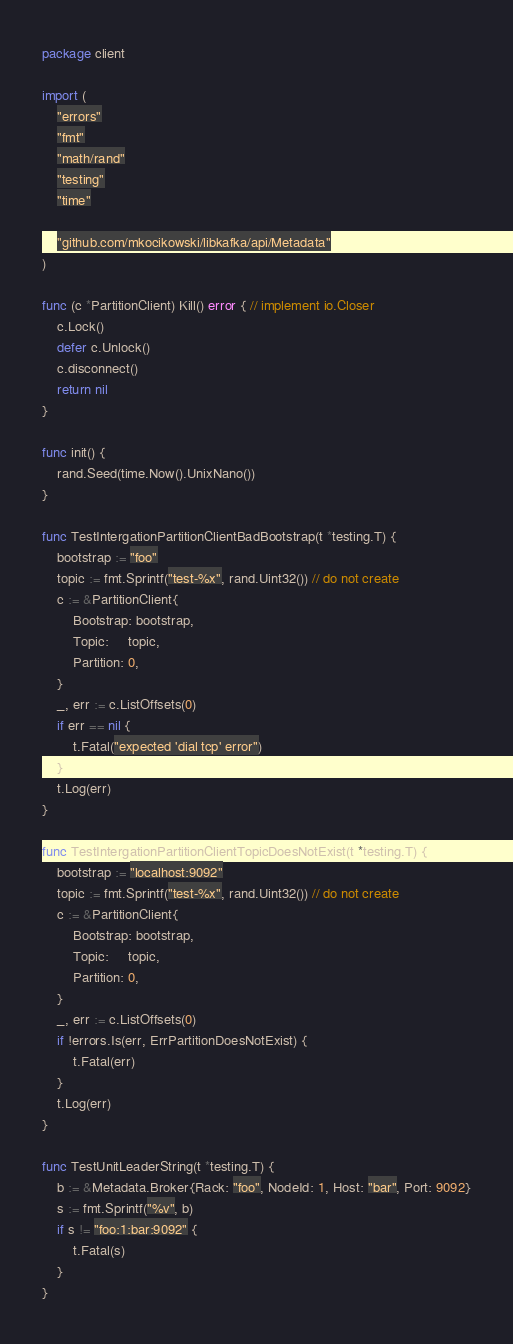Convert code to text. <code><loc_0><loc_0><loc_500><loc_500><_Go_>package client

import (
	"errors"
	"fmt"
	"math/rand"
	"testing"
	"time"

	"github.com/mkocikowski/libkafka/api/Metadata"
)

func (c *PartitionClient) Kill() error { // implement io.Closer
	c.Lock()
	defer c.Unlock()
	c.disconnect()
	return nil
}

func init() {
	rand.Seed(time.Now().UnixNano())
}

func TestIntergationPartitionClientBadBootstrap(t *testing.T) {
	bootstrap := "foo"
	topic := fmt.Sprintf("test-%x", rand.Uint32()) // do not create
	c := &PartitionClient{
		Bootstrap: bootstrap,
		Topic:     topic,
		Partition: 0,
	}
	_, err := c.ListOffsets(0)
	if err == nil {
		t.Fatal("expected 'dial tcp' error")
	}
	t.Log(err)
}

func TestIntergationPartitionClientTopicDoesNotExist(t *testing.T) {
	bootstrap := "localhost:9092"
	topic := fmt.Sprintf("test-%x", rand.Uint32()) // do not create
	c := &PartitionClient{
		Bootstrap: bootstrap,
		Topic:     topic,
		Partition: 0,
	}
	_, err := c.ListOffsets(0)
	if !errors.Is(err, ErrPartitionDoesNotExist) {
		t.Fatal(err)
	}
	t.Log(err)
}

func TestUnitLeaderString(t *testing.T) {
	b := &Metadata.Broker{Rack: "foo", NodeId: 1, Host: "bar", Port: 9092}
	s := fmt.Sprintf("%v", b)
	if s != "foo:1:bar:9092" {
		t.Fatal(s)
	}
}
</code> 